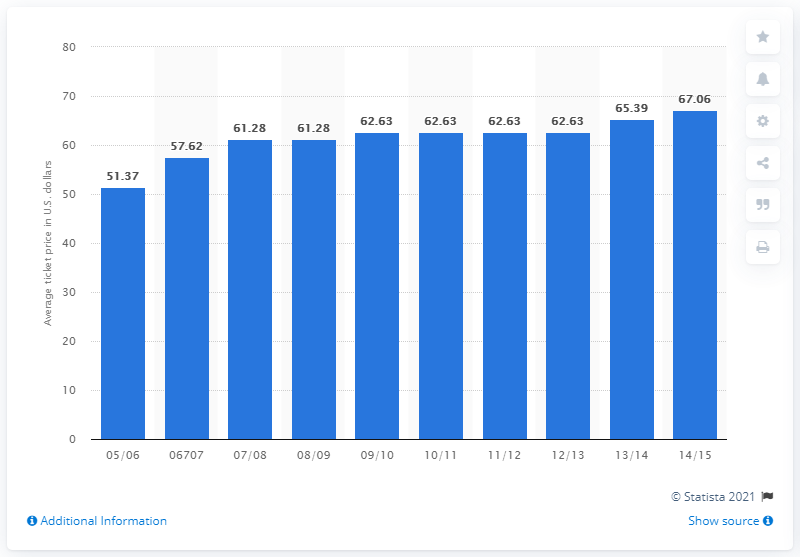Highlight a few significant elements in this photo. In the 2005/2006 season, the average ticket price was 51.37. 